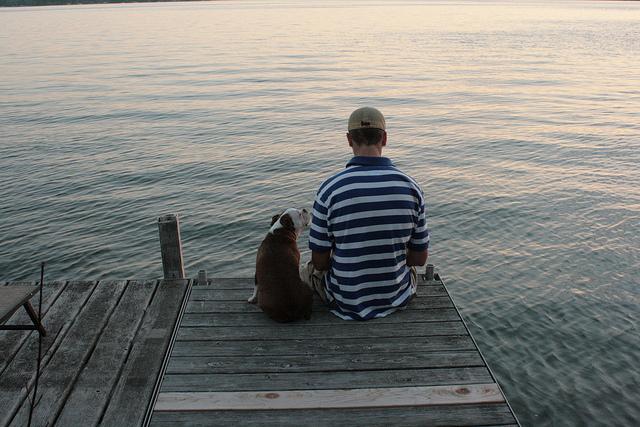Are the man and the dog looking at the sea?
Answer briefly. Yes. What is this man likely waiting for?
Keep it brief. Fish. Is the dog smaller than the man?
Concise answer only. Yes. What is the man doing?
Be succinct. Sitting. Are they waiting for a ferry?
Give a very brief answer. No. 